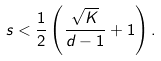<formula> <loc_0><loc_0><loc_500><loc_500>s < \frac { 1 } { 2 } \left ( \frac { \sqrt { K } } { d - 1 } + 1 \right ) .</formula> 